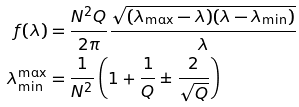<formula> <loc_0><loc_0><loc_500><loc_500>f ( \lambda ) & = \frac { N ^ { 2 } Q } { 2 \pi } \frac { \sqrt { ( \lambda _ { \max } - \lambda ) ( \lambda - \lambda _ { \min } ) } } { \lambda } \\ \lambda _ { \min } ^ { \max } & = \frac { 1 } { N ^ { 2 } } \left ( 1 + \frac { 1 } { Q } \pm \frac { 2 } { \sqrt { Q } } \right )</formula> 